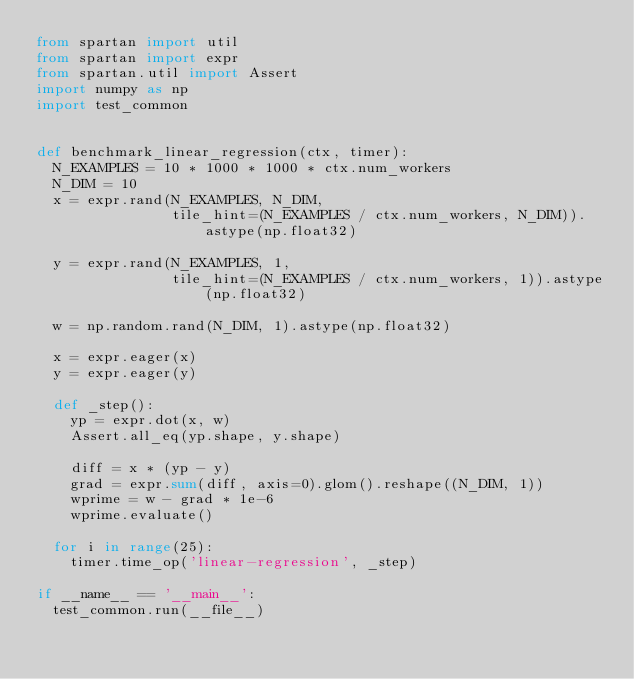<code> <loc_0><loc_0><loc_500><loc_500><_Python_>from spartan import util
from spartan import expr
from spartan.util import Assert
import numpy as np
import test_common


def benchmark_linear_regression(ctx, timer):
  N_EXAMPLES = 10 * 1000 * 1000 * ctx.num_workers
  N_DIM = 10
  x = expr.rand(N_EXAMPLES, N_DIM,
                tile_hint=(N_EXAMPLES / ctx.num_workers, N_DIM)).astype(np.float32)

  y = expr.rand(N_EXAMPLES, 1,
                tile_hint=(N_EXAMPLES / ctx.num_workers, 1)).astype(np.float32)

  w = np.random.rand(N_DIM, 1).astype(np.float32)

  x = expr.eager(x)
  y = expr.eager(y)

  def _step():
    yp = expr.dot(x, w)
    Assert.all_eq(yp.shape, y.shape)

    diff = x * (yp - y)
    grad = expr.sum(diff, axis=0).glom().reshape((N_DIM, 1))
    wprime = w - grad * 1e-6
    wprime.evaluate()

  for i in range(25):
    timer.time_op('linear-regression', _step)

if __name__ == '__main__':
  test_common.run(__file__)
</code> 